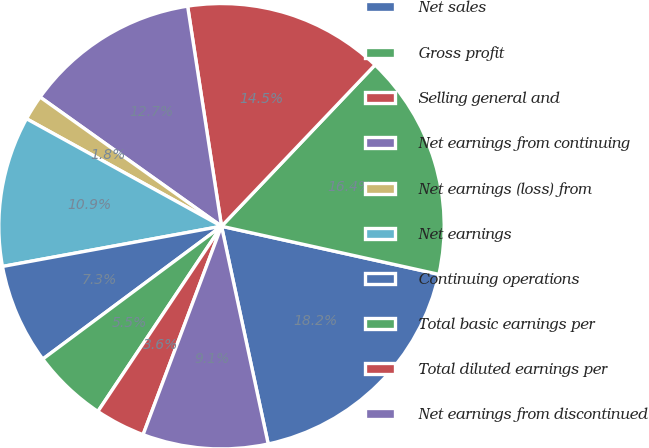Convert chart to OTSL. <chart><loc_0><loc_0><loc_500><loc_500><pie_chart><fcel>Net sales<fcel>Gross profit<fcel>Selling general and<fcel>Net earnings from continuing<fcel>Net earnings (loss) from<fcel>Net earnings<fcel>Continuing operations<fcel>Total basic earnings per<fcel>Total diluted earnings per<fcel>Net earnings from discontinued<nl><fcel>18.17%<fcel>16.36%<fcel>14.54%<fcel>12.72%<fcel>1.83%<fcel>10.91%<fcel>7.28%<fcel>5.46%<fcel>3.64%<fcel>9.09%<nl></chart> 